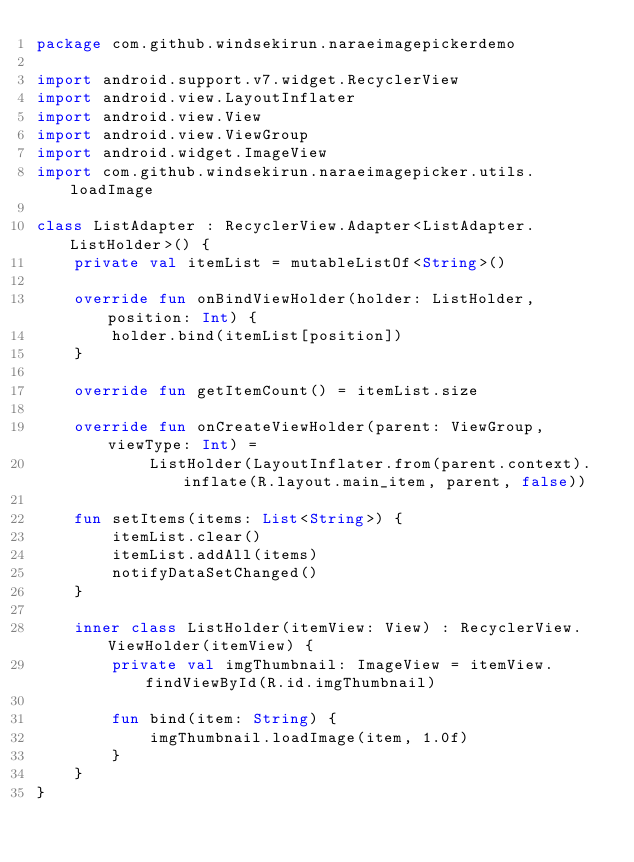<code> <loc_0><loc_0><loc_500><loc_500><_Kotlin_>package com.github.windsekirun.naraeimagepickerdemo

import android.support.v7.widget.RecyclerView
import android.view.LayoutInflater
import android.view.View
import android.view.ViewGroup
import android.widget.ImageView
import com.github.windsekirun.naraeimagepicker.utils.loadImage

class ListAdapter : RecyclerView.Adapter<ListAdapter.ListHolder>() {
    private val itemList = mutableListOf<String>()

    override fun onBindViewHolder(holder: ListHolder, position: Int) {
        holder.bind(itemList[position])
    }

    override fun getItemCount() = itemList.size

    override fun onCreateViewHolder(parent: ViewGroup, viewType: Int) =
            ListHolder(LayoutInflater.from(parent.context).inflate(R.layout.main_item, parent, false))

    fun setItems(items: List<String>) {
        itemList.clear()
        itemList.addAll(items)
        notifyDataSetChanged()
    }

    inner class ListHolder(itemView: View) : RecyclerView.ViewHolder(itemView) {
        private val imgThumbnail: ImageView = itemView.findViewById(R.id.imgThumbnail)

        fun bind(item: String) {
            imgThumbnail.loadImage(item, 1.0f)
        }
    }
}</code> 